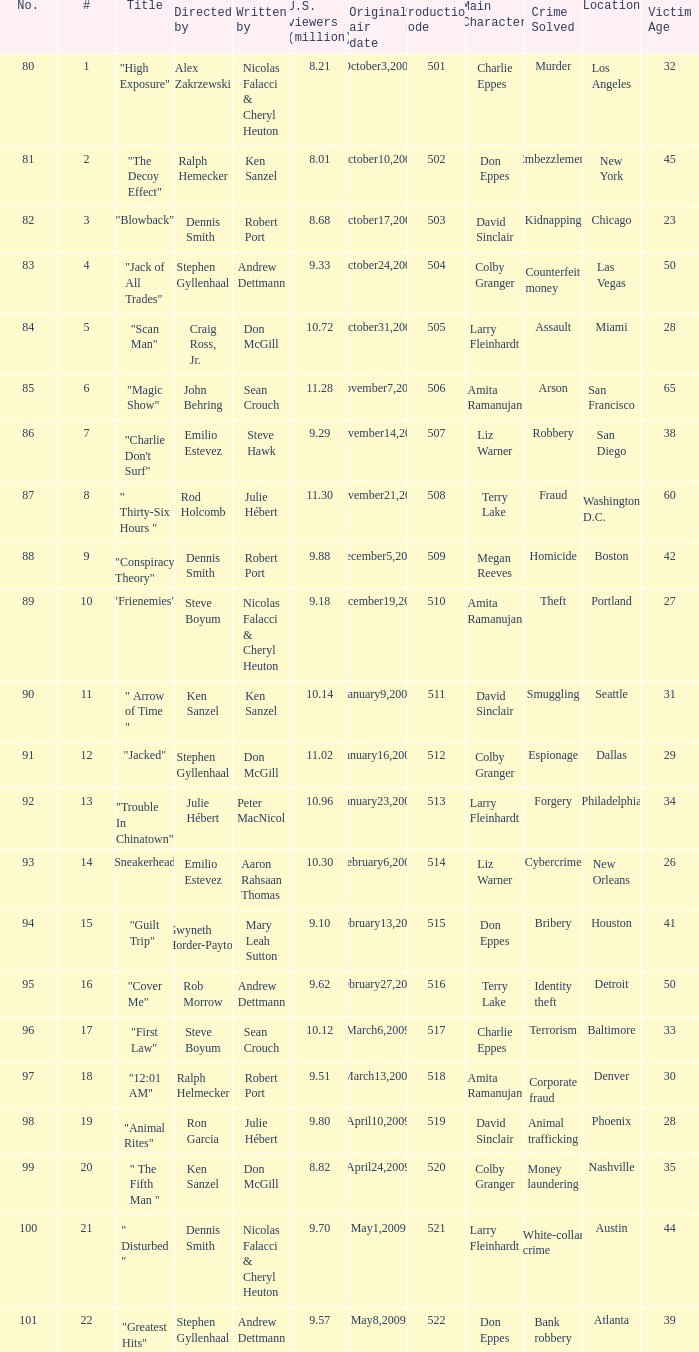Who wrote the episode with the production code 519? Julie Hébert. 